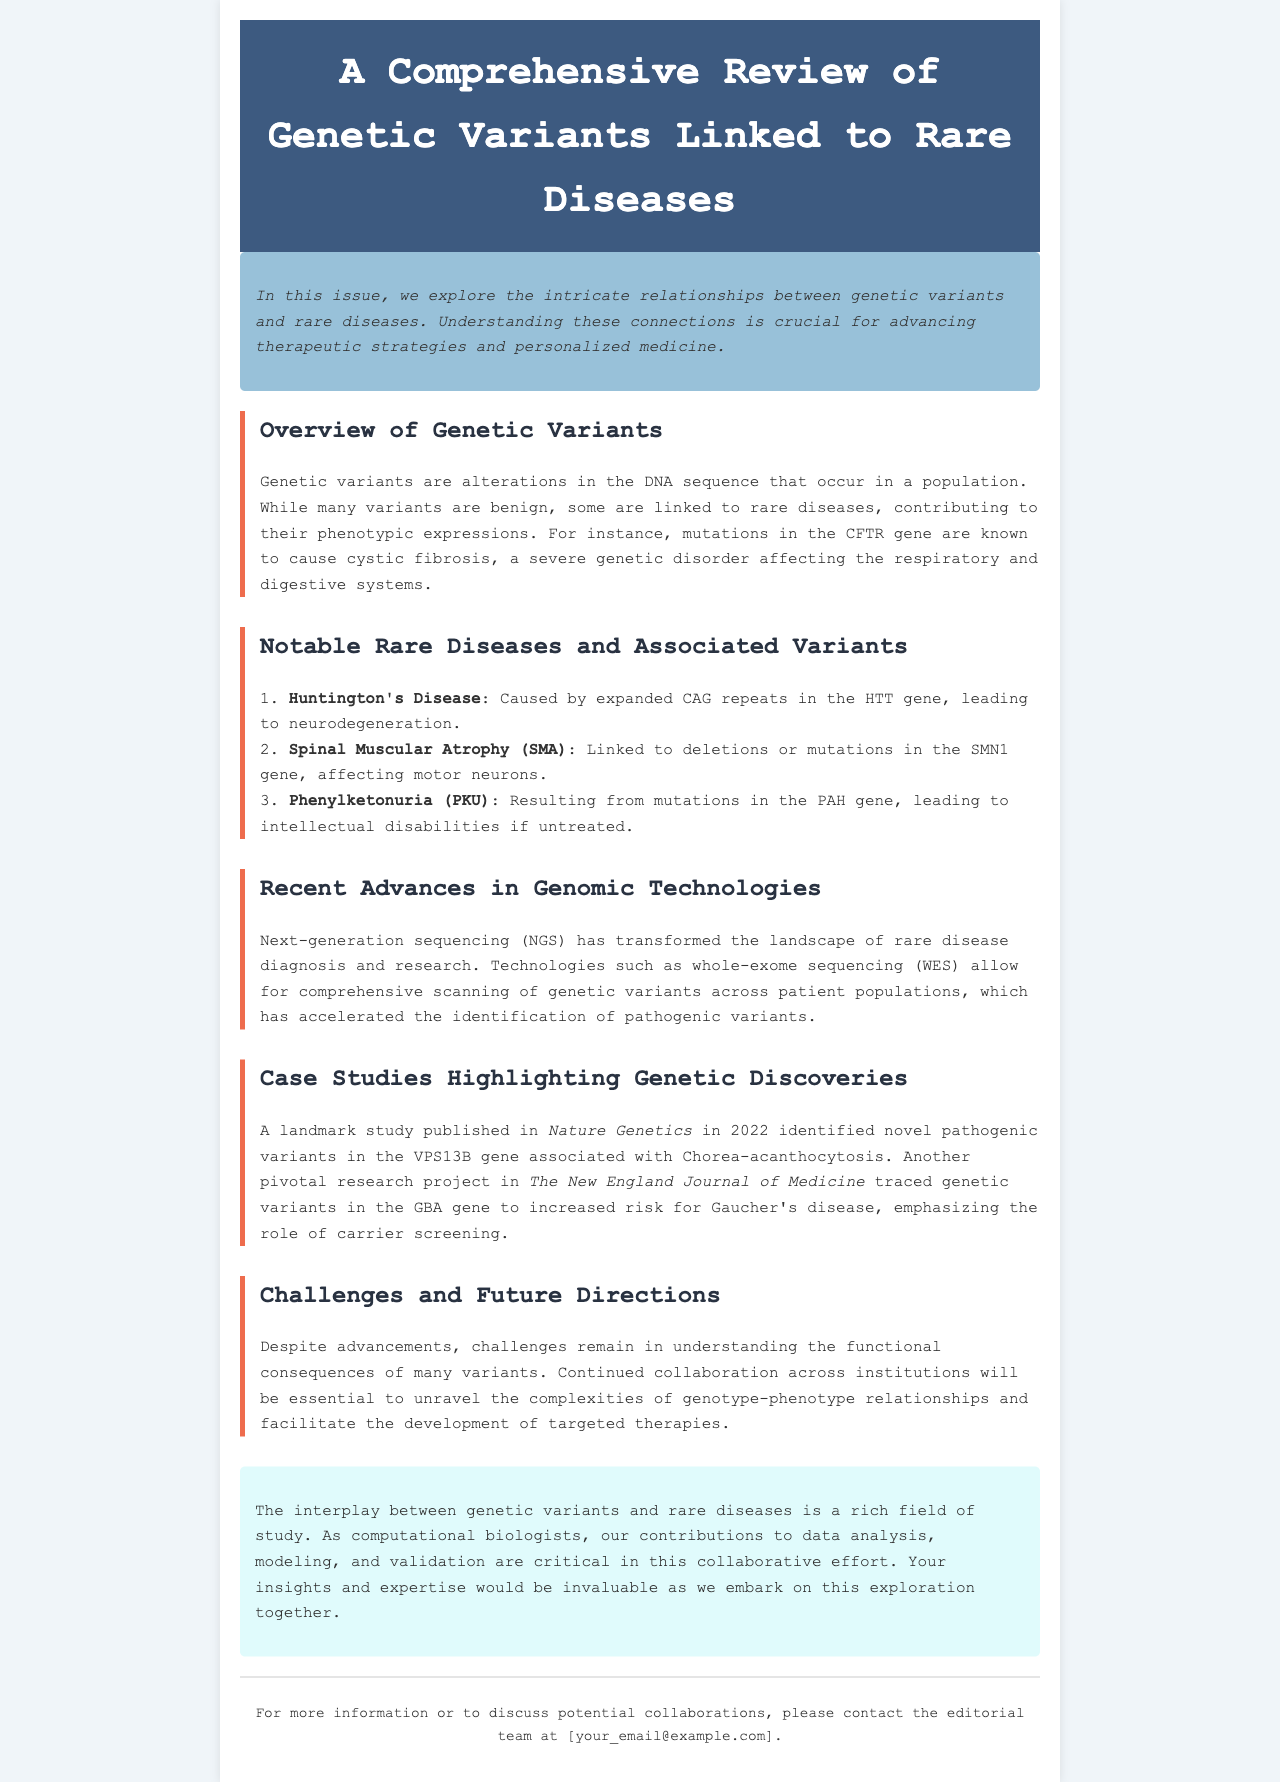What is the main focus of this newsletter? The newsletter explores the intricate relationships between genetic variants and rare diseases, which is essential for advancing therapeutic strategies and personalized medicine.
Answer: Genetic variants and rare diseases What gene is associated with cystic fibrosis? Cystic fibrosis is caused by mutations in this gene, highlighting its role in a severe genetic disorder.
Answer: CFTR Which technology has transformed rare disease diagnosis? The document mentions that this technology has revolutionized the way rare diseases are diagnosed and researched.
Answer: Next-generation sequencing What is a specific genetic variant linked to Huntington's Disease? The variant specifically mentioned in relation to Huntington's Disease is crucial for understanding its underlying mechanism.
Answer: Expanded CAG repeats In what year was a significant study on VPS13B published? This year is noted in the document, showcasing an important discovery in the field of genetic research.
Answer: 2022 What is a key challenge mentioned regarding genetic variants? This challenge is critical for advancing the understanding of genetic diseases and is mentioned in the context of the document.
Answer: Understanding functional consequences How are rare diseases and genetic variants related in the document? The relationships between these two elements drive the research and findings presented in the newsletter.
Answer: Intricate relationships What journal published research tracing variants in the GBA gene? This journal is noted for its pivotal research related to Gaucher's disease.
Answer: The New England Journal of Medicine What type of collaborations does the document emphasize? This type of collaboration is essential for advancing research in the area of genetic variants and rare diseases.
Answer: Continued collaboration across institutions 